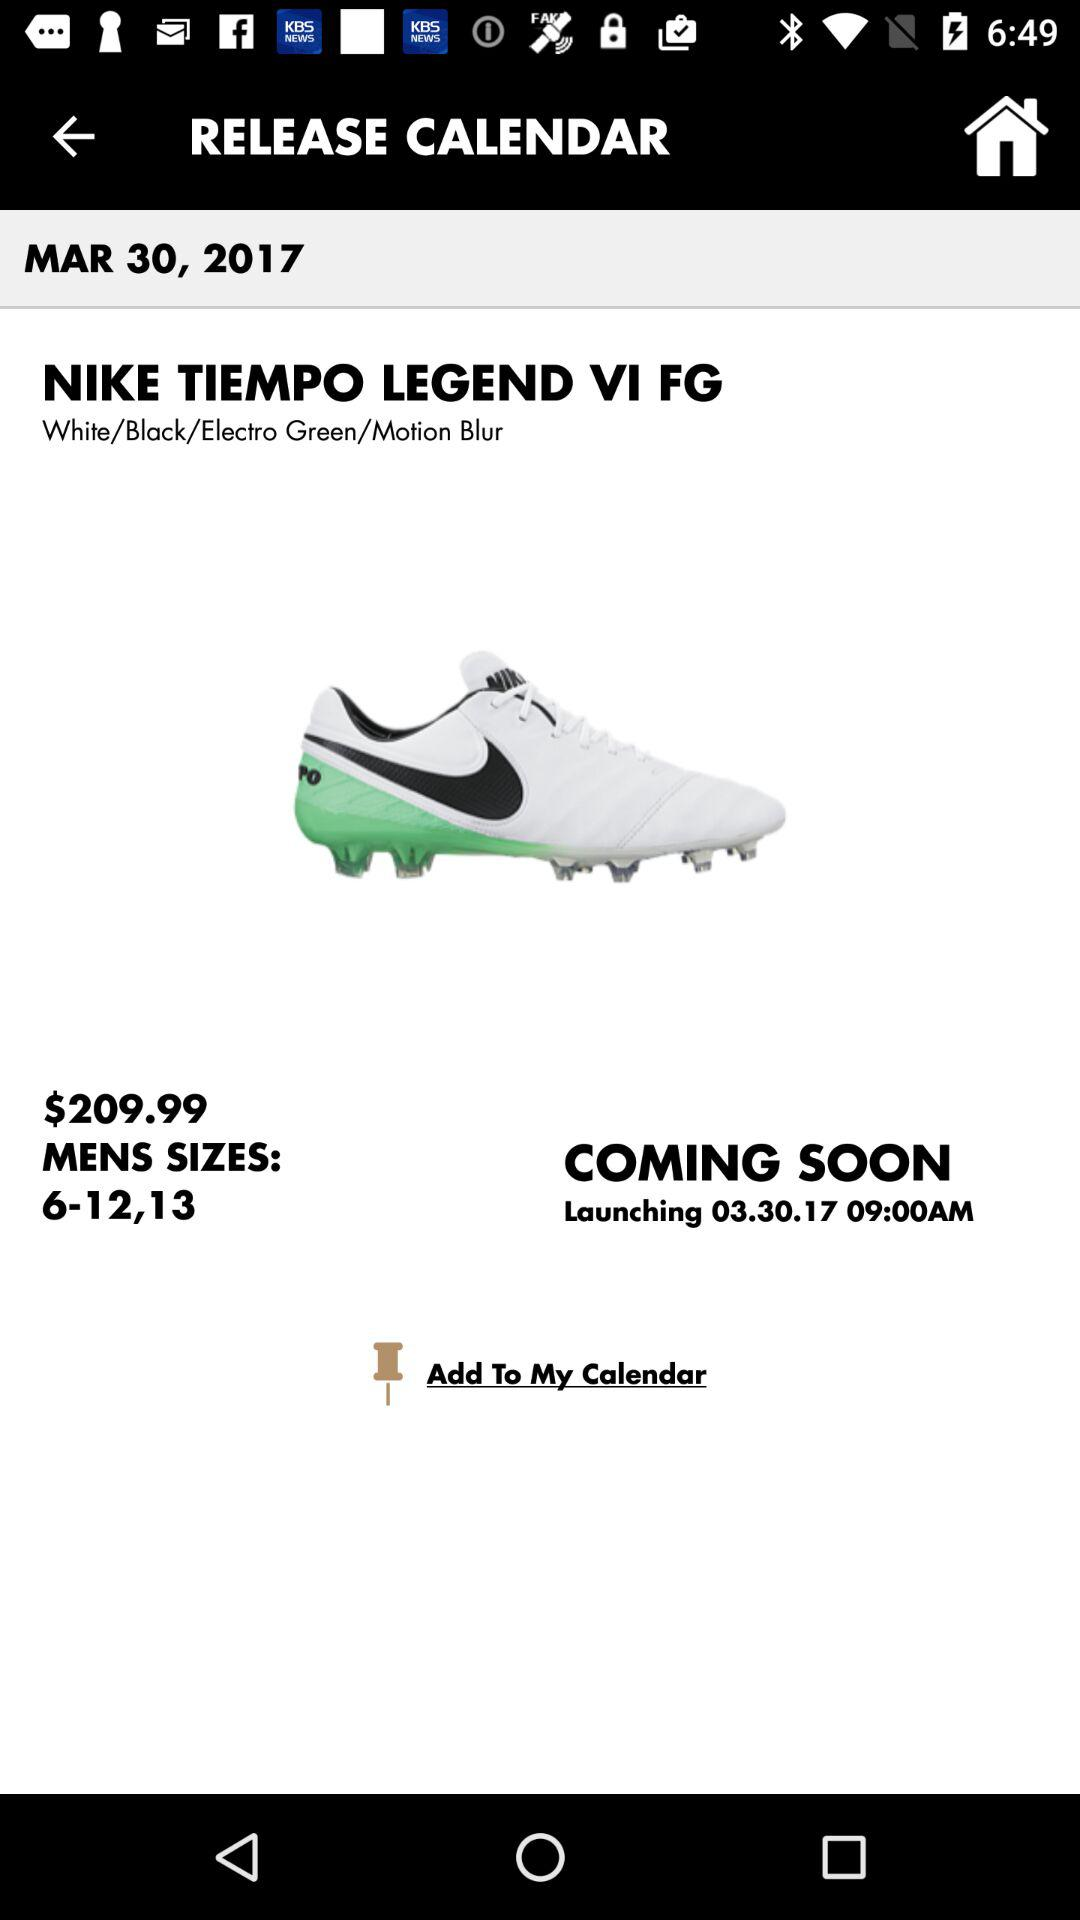What is the brand name? The brand name is "NIKE". 